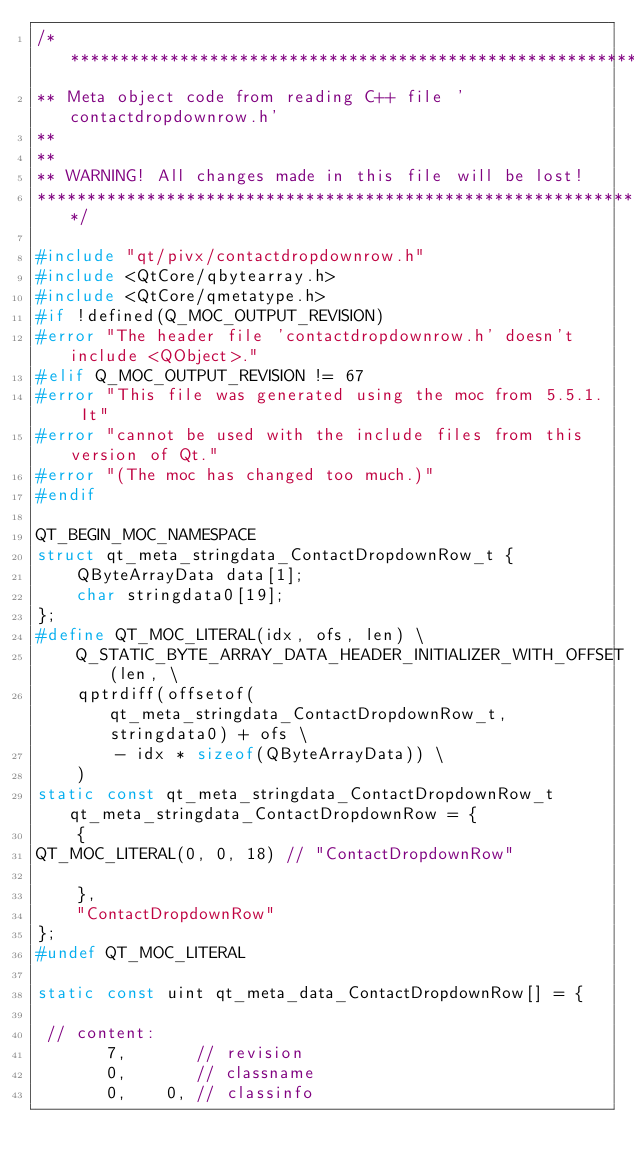Convert code to text. <code><loc_0><loc_0><loc_500><loc_500><_C++_>/****************************************************************************
** Meta object code from reading C++ file 'contactdropdownrow.h'
**
**
** WARNING! All changes made in this file will be lost!
*****************************************************************************/

#include "qt/pivx/contactdropdownrow.h"
#include <QtCore/qbytearray.h>
#include <QtCore/qmetatype.h>
#if !defined(Q_MOC_OUTPUT_REVISION)
#error "The header file 'contactdropdownrow.h' doesn't include <QObject>."
#elif Q_MOC_OUTPUT_REVISION != 67
#error "This file was generated using the moc from 5.5.1. It"
#error "cannot be used with the include files from this version of Qt."
#error "(The moc has changed too much.)"
#endif

QT_BEGIN_MOC_NAMESPACE
struct qt_meta_stringdata_ContactDropdownRow_t {
    QByteArrayData data[1];
    char stringdata0[19];
};
#define QT_MOC_LITERAL(idx, ofs, len) \
    Q_STATIC_BYTE_ARRAY_DATA_HEADER_INITIALIZER_WITH_OFFSET(len, \
    qptrdiff(offsetof(qt_meta_stringdata_ContactDropdownRow_t, stringdata0) + ofs \
        - idx * sizeof(QByteArrayData)) \
    )
static const qt_meta_stringdata_ContactDropdownRow_t qt_meta_stringdata_ContactDropdownRow = {
    {
QT_MOC_LITERAL(0, 0, 18) // "ContactDropdownRow"

    },
    "ContactDropdownRow"
};
#undef QT_MOC_LITERAL

static const uint qt_meta_data_ContactDropdownRow[] = {

 // content:
       7,       // revision
       0,       // classname
       0,    0, // classinfo</code> 